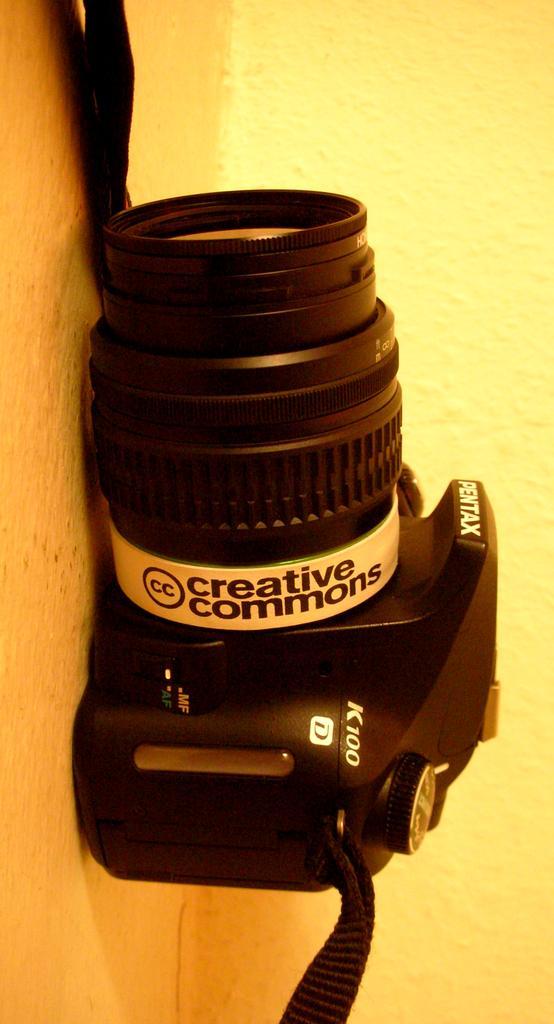How would you summarize this image in a sentence or two? On this surface we can see a camera. Something written on this camera. Background there is a wall. 